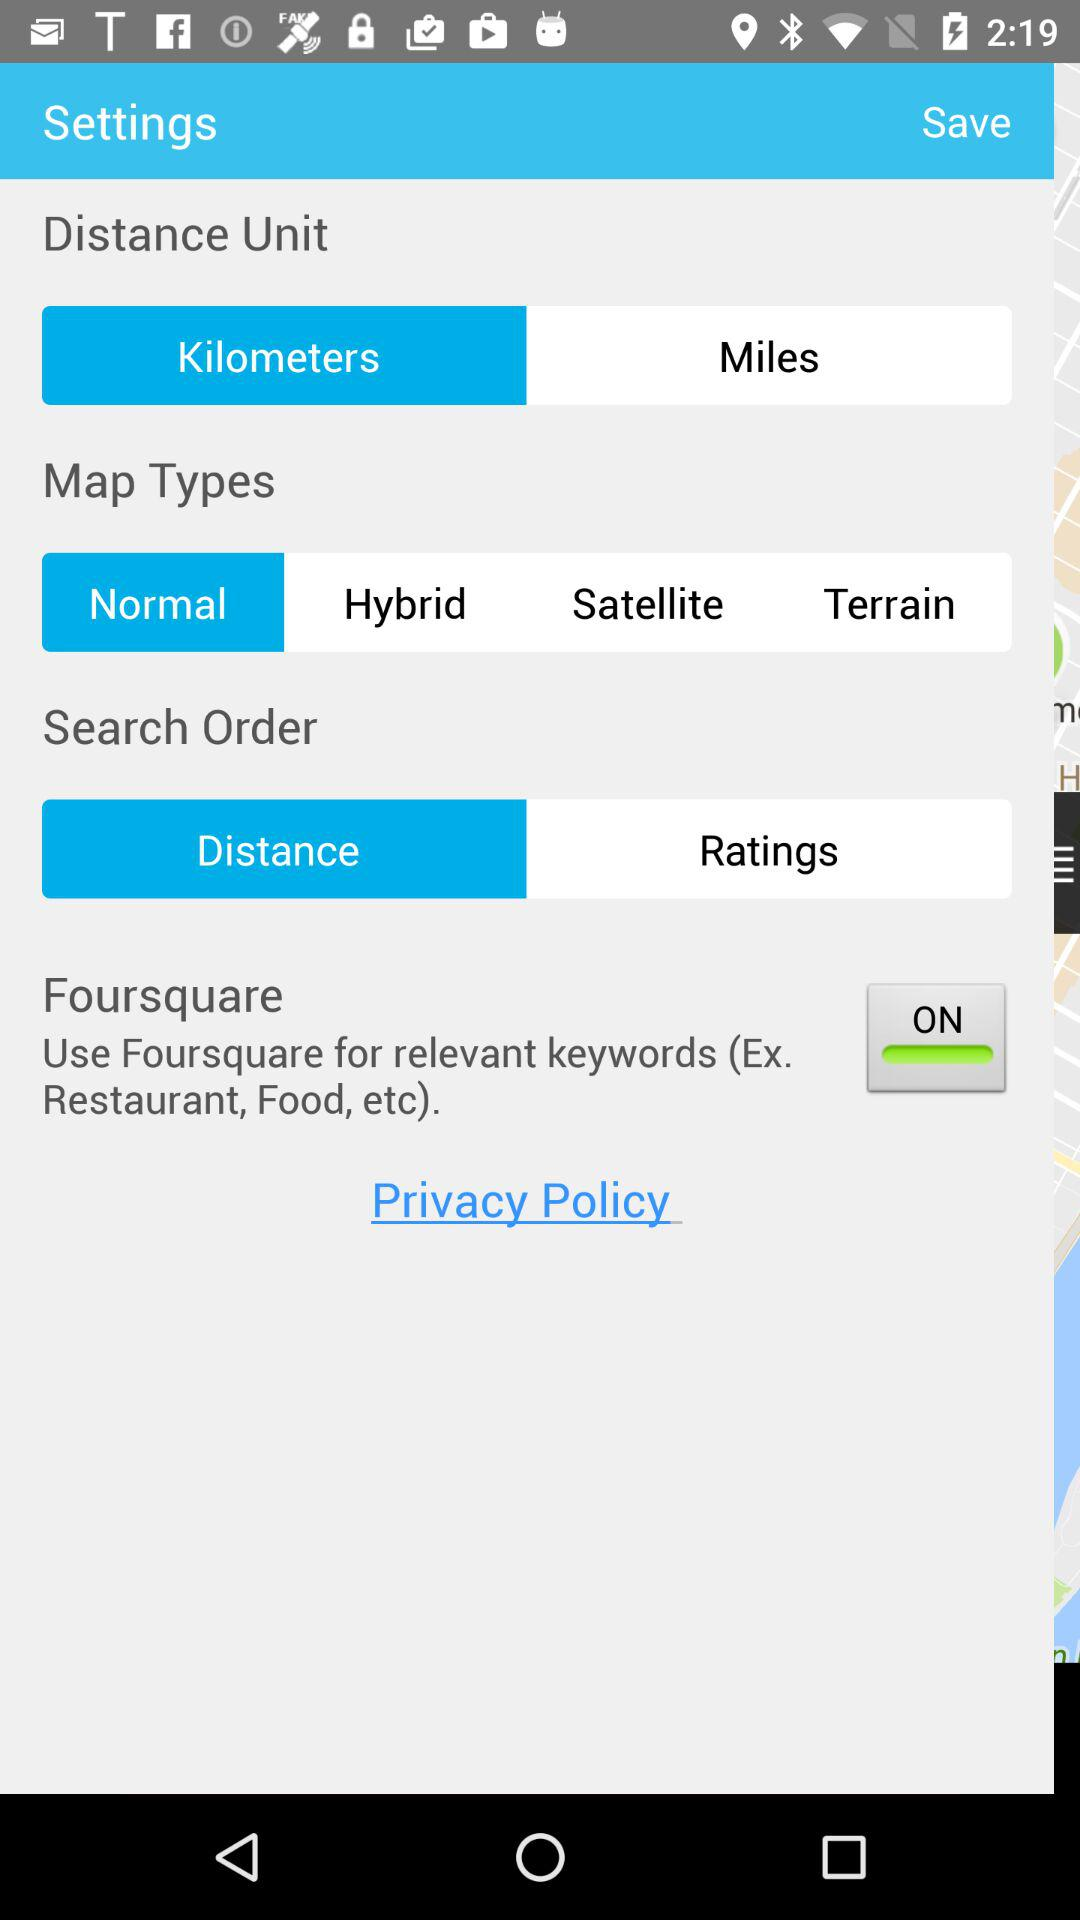What is the status of "Foursquare"? "Foursquare" is turned on. 